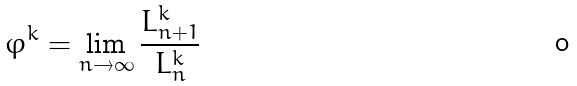Convert formula to latex. <formula><loc_0><loc_0><loc_500><loc_500>\varphi ^ { k } = \lim _ { n \rightarrow \infty } \frac { L ^ { k } _ { n + 1 } } { L ^ { k } _ { n } }</formula> 